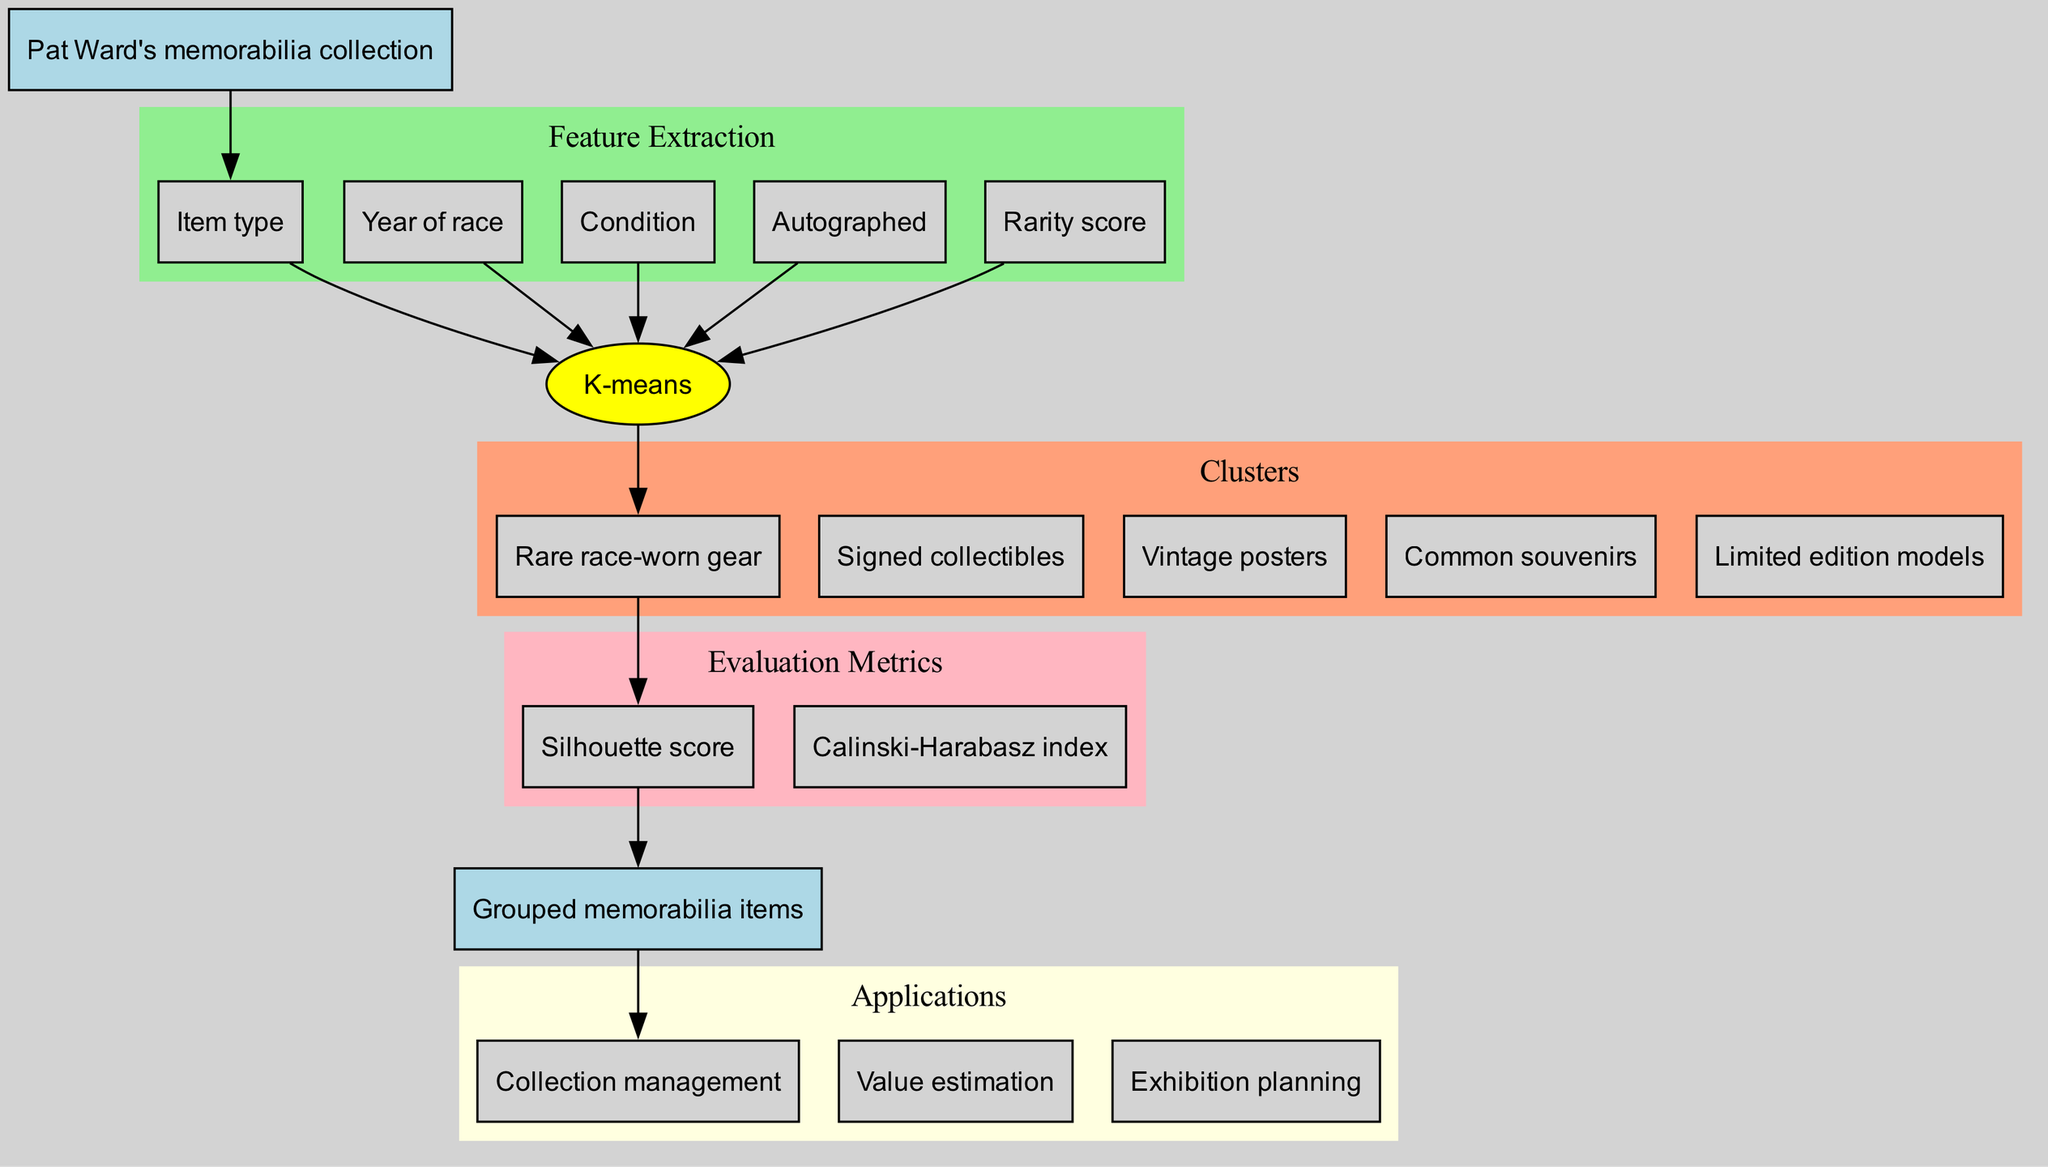What is the clustering algorithm used in the diagram? The diagram explicitly states that the clustering algorithm used is K-means, which is represented as an ellipse node labeled with this name.
Answer: K-means How many clusters are defined in the diagram? By counting the separate nodes listed under the "Clusters" section, we can see there are five distinct clusters identified in the diagram.
Answer: 5 What is the first feature extracted from the collection? The first feature listed in the "Feature Extraction" section is "Item type," which is the first rectangle node in that subgraph.
Answer: Item type Which application is connected to the output of the diagram? The output of the diagram leads to the first application node, which is labeled "Collection management," making it clear that this application is directly linked to the output.
Answer: Collection management What is the evaluation metric that appears first in the diagram? The evaluation metrics are listed in order, and the first metric mentioned in the "Evaluation Metrics" section is "Silhouette score," which is the first node in that subgraph.
Answer: Silhouette score Which cluster would likely include items with the highest rarity? The "Rare race-worn gear" cluster is specifically labeled to denote that it includes the items from the collection that are rare and of high value, distinguishing it from other clusters.
Answer: Rare race-worn gear What color represents the feature extraction section in the diagram? The "Feature Extraction" section is represented with a filled color of light green, as indicated in the diagram subgraph attributes.
Answer: Light green How are the edges connected from the algorithm to the clusters? The edges from the algorithm node lead to several cluster nodes. There is one directed edge from the algorithm node to each of the five cluster nodes, representing a one-to-one relationship.
Answer: One directed edge per cluster What is the relationship between the output node and the applications? The output node connects to the applications through directed edges that lead to each application node listed, indicating that the output influences or is relevant to all applications specified in the diagram.
Answer: Directed edges from output node to application nodes 